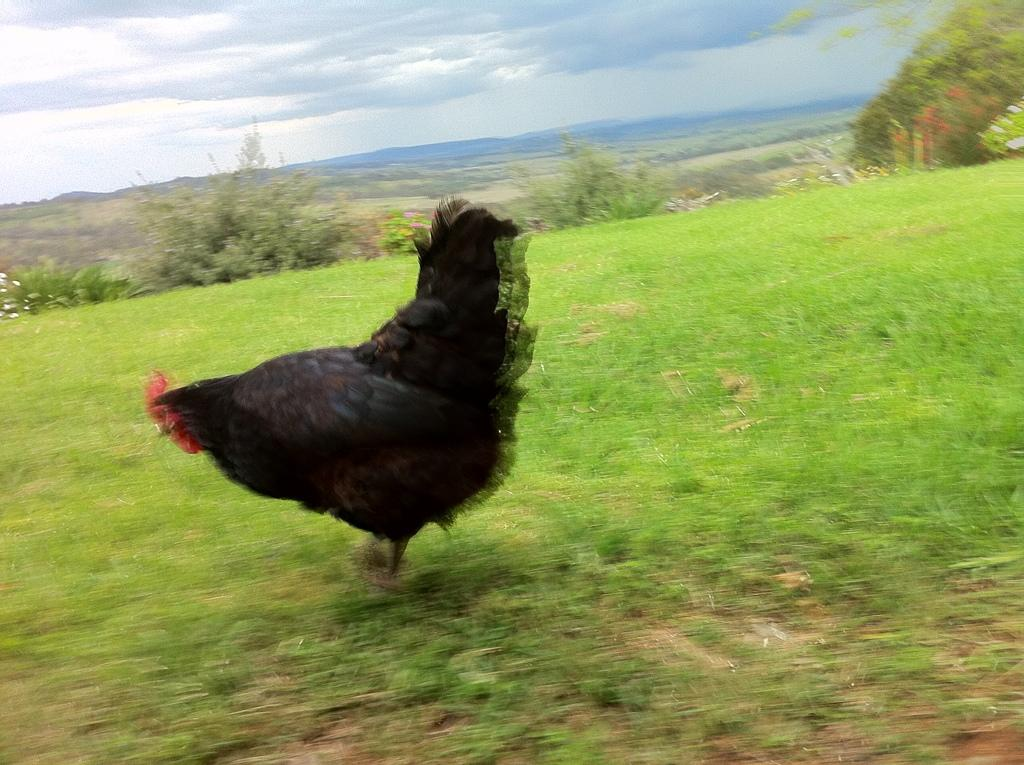What is the primary vegetation covering the land in the image? The land is covered with grass. What type of animal can be seen in the image? There is a hen in the image. What can be seen in the background of the image? There are plants in the background. How would you describe the sky in the image? The sky is cloudy. How many kilograms of rice can be seen in the image? There is no rice present in the image. Is there any indication of a birth occurring in the image? There is no indication of a birth or any related activity in the image. 